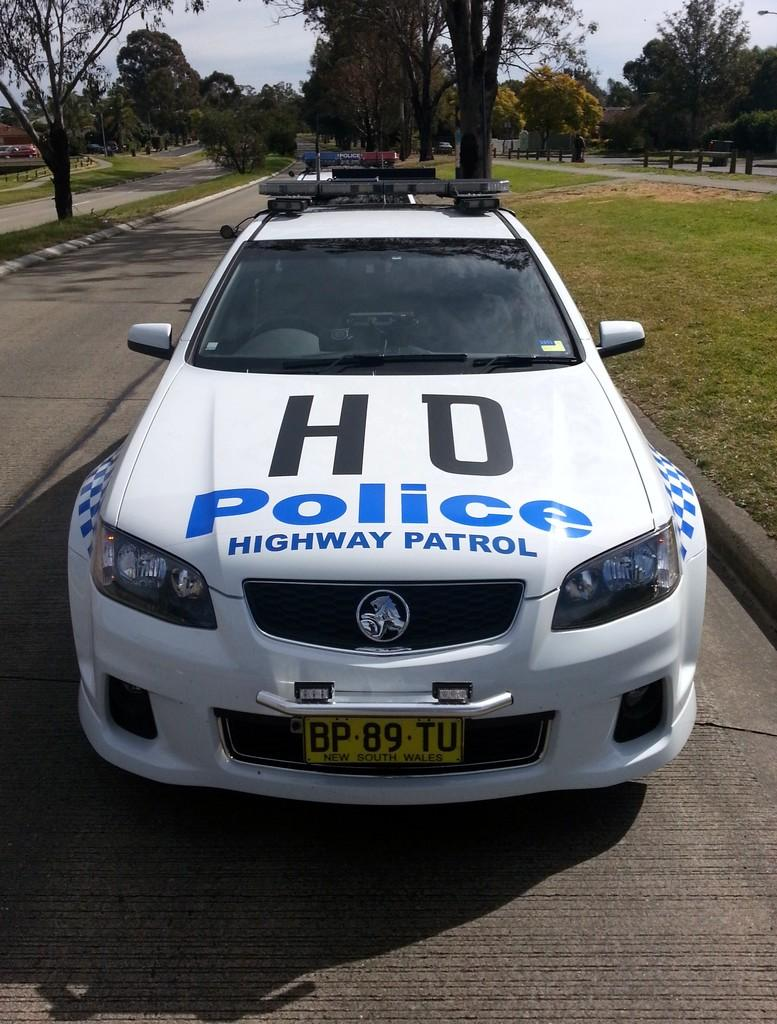What types of vehicles can be seen on the roads in the image? There are motor vehicles on the roads in the image. What safety feature is present in the image? Barrier poles are present in the image. What type of vegetation is visible in the image? There are trees visible in the image. What is visible in the background of the image? The sky is visible in the image. What can be observed in the sky? Clouds are present in the sky. What type of expansion is visible in the image? There is no specific expansion mentioned or visible in the image. Can you identify the crook in the image? There is no crook present in the image. 